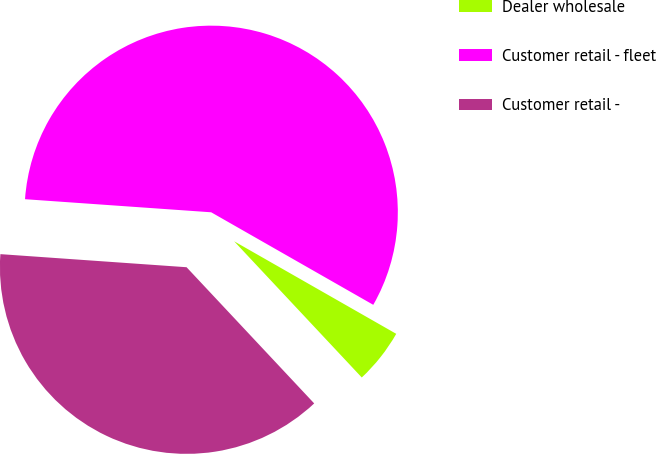<chart> <loc_0><loc_0><loc_500><loc_500><pie_chart><fcel>Dealer wholesale<fcel>Customer retail - fleet<fcel>Customer retail -<nl><fcel>4.76%<fcel>57.14%<fcel>38.1%<nl></chart> 